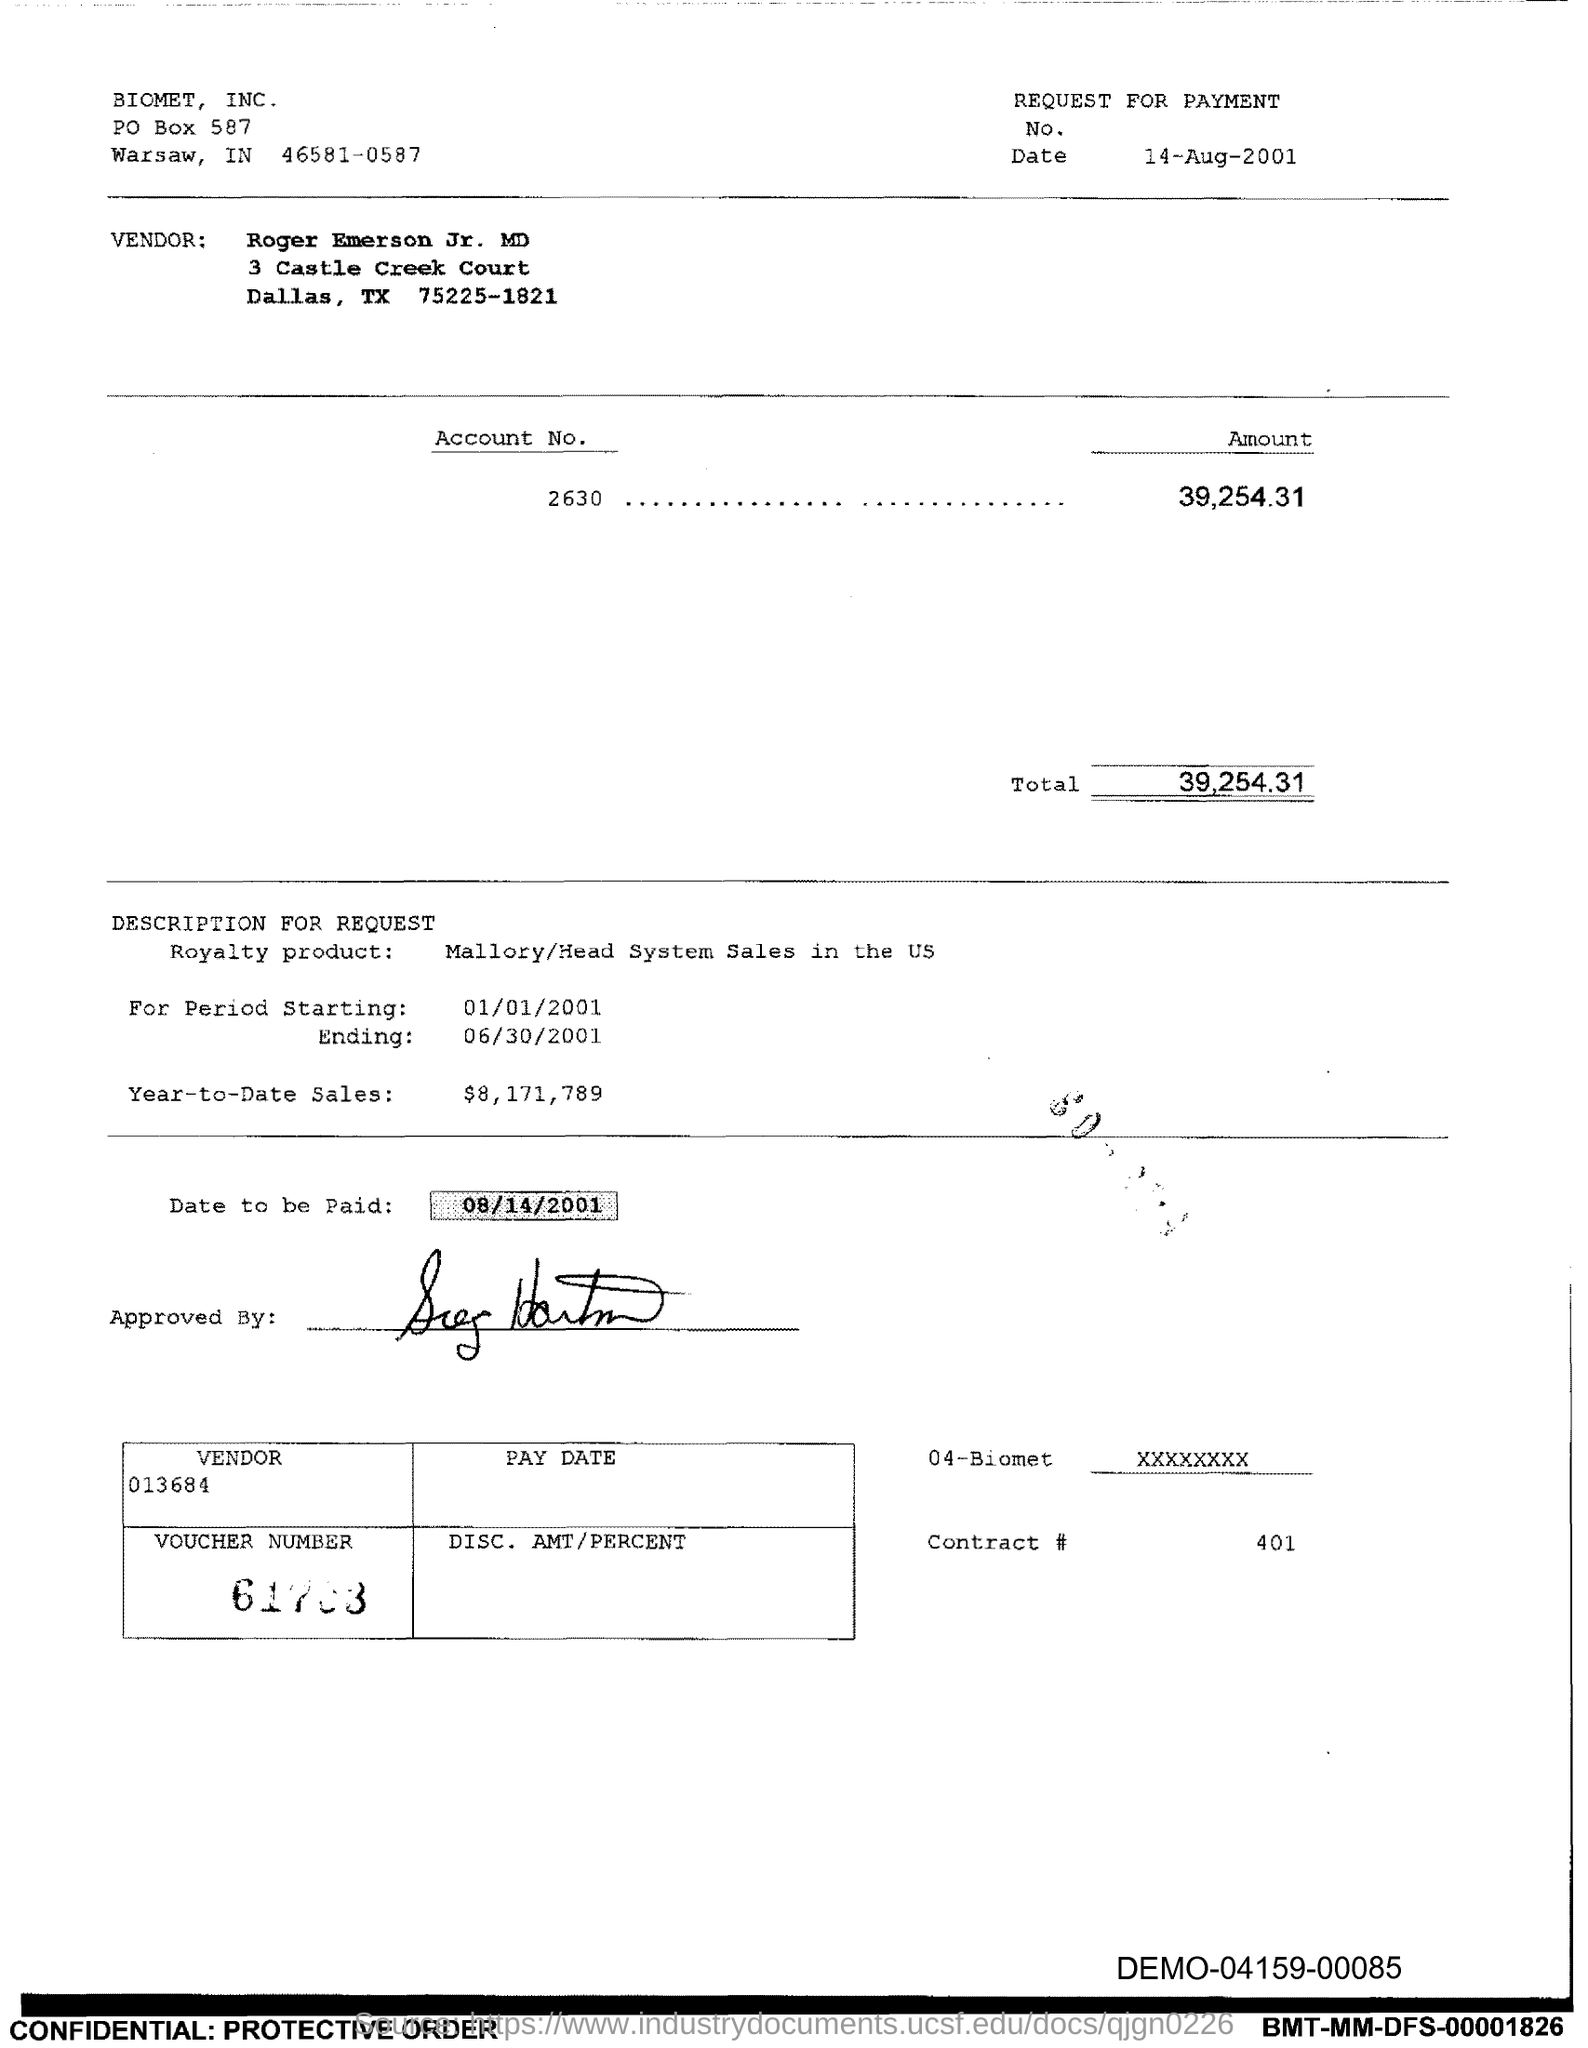Draw attention to some important aspects in this diagram. Who is the vendor? Roger Emerson Jr., MD. The ending period is June 30, 2001. The date is August 14, 2001. The amount is 39,254.31. What is the date to be paid? It is 08/14/2001. 